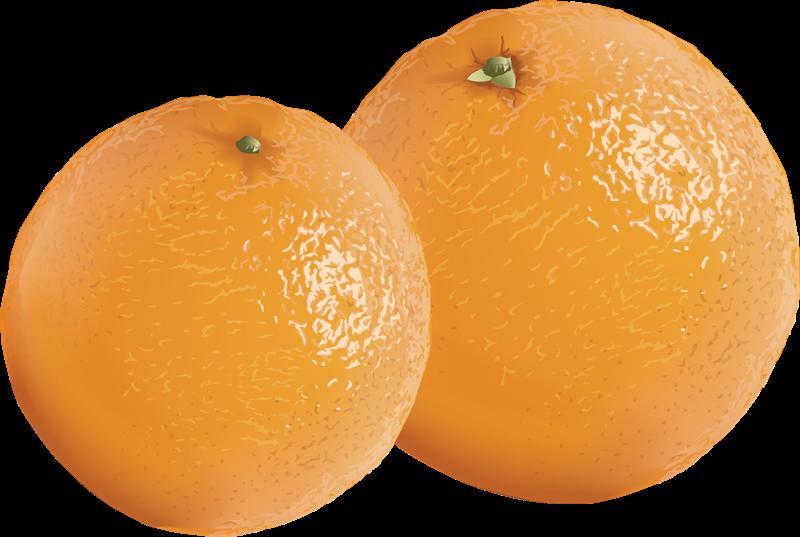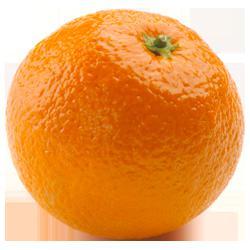The first image is the image on the left, the second image is the image on the right. For the images displayed, is the sentence "In total, the images contain the equivalent of four oranges." factually correct? Answer yes or no. No. 